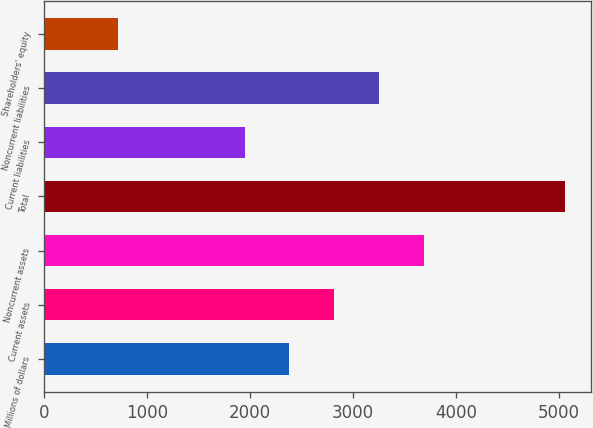Convert chart. <chart><loc_0><loc_0><loc_500><loc_500><bar_chart><fcel>Millions of dollars<fcel>Current assets<fcel>Noncurrent assets<fcel>Total<fcel>Current liabilities<fcel>Noncurrent liabilities<fcel>Shareholders' equity<nl><fcel>2384.4<fcel>2818.8<fcel>3687.6<fcel>5062<fcel>1950<fcel>3253.2<fcel>718<nl></chart> 